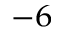<formula> <loc_0><loc_0><loc_500><loc_500>^ { - 6 }</formula> 